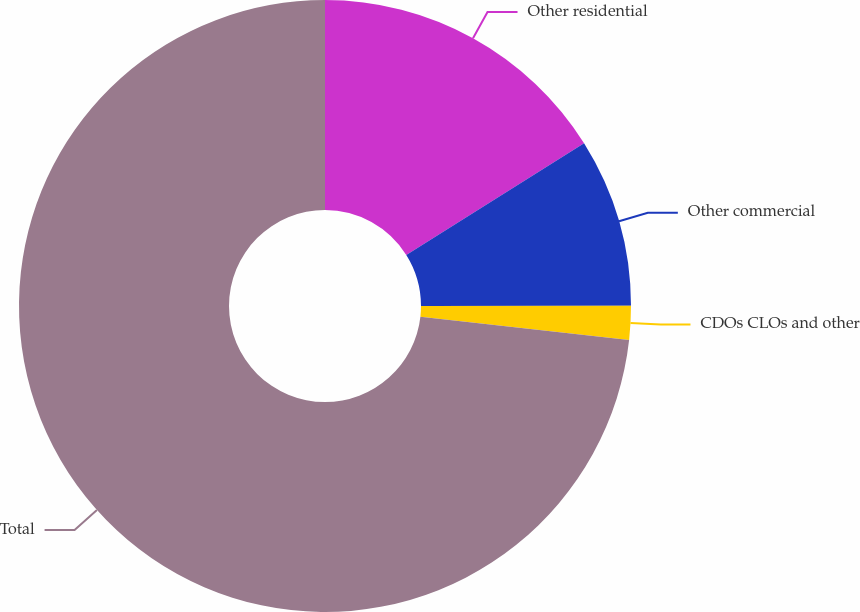Convert chart. <chart><loc_0><loc_0><loc_500><loc_500><pie_chart><fcel>Other residential<fcel>Other commercial<fcel>CDOs CLOs and other<fcel>Total<nl><fcel>16.07%<fcel>8.92%<fcel>1.78%<fcel>73.23%<nl></chart> 